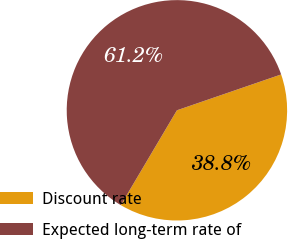Convert chart to OTSL. <chart><loc_0><loc_0><loc_500><loc_500><pie_chart><fcel>Discount rate<fcel>Expected long-term rate of<nl><fcel>38.78%<fcel>61.22%<nl></chart> 